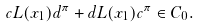<formula> <loc_0><loc_0><loc_500><loc_500>c L ( x _ { 1 } ) d ^ { \pi } + d L ( x _ { 1 } ) c ^ { \pi } \in C _ { 0 } .</formula> 